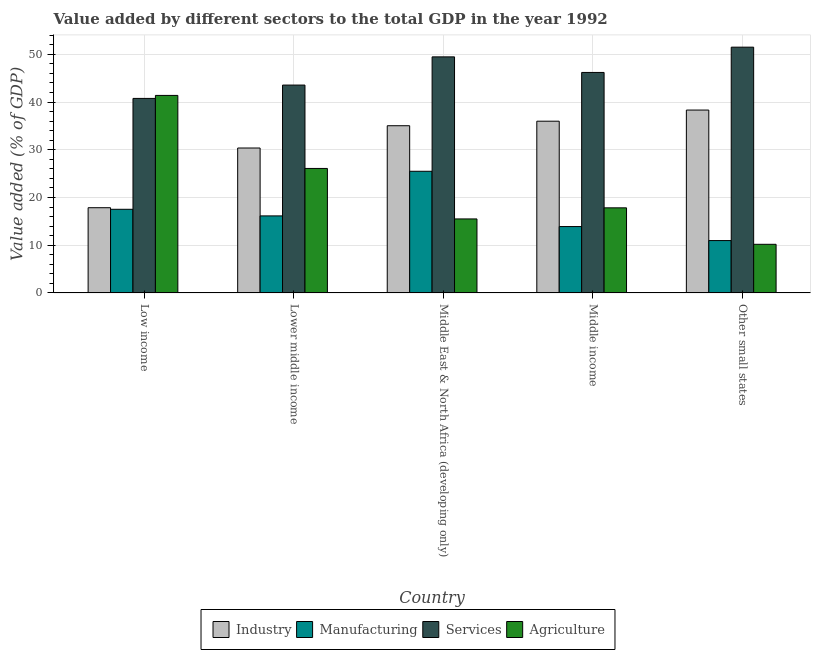How many different coloured bars are there?
Keep it short and to the point. 4. How many groups of bars are there?
Give a very brief answer. 5. How many bars are there on the 3rd tick from the left?
Provide a succinct answer. 4. What is the value added by services sector in Other small states?
Your answer should be compact. 51.49. Across all countries, what is the maximum value added by agricultural sector?
Provide a succinct answer. 41.39. Across all countries, what is the minimum value added by manufacturing sector?
Your answer should be very brief. 10.97. In which country was the value added by industrial sector maximum?
Ensure brevity in your answer.  Other small states. In which country was the value added by industrial sector minimum?
Make the answer very short. Low income. What is the total value added by manufacturing sector in the graph?
Provide a short and direct response. 84.04. What is the difference between the value added by agricultural sector in Low income and that in Middle income?
Ensure brevity in your answer.  23.56. What is the difference between the value added by agricultural sector in Low income and the value added by services sector in Middle income?
Make the answer very short. -4.81. What is the average value added by industrial sector per country?
Provide a short and direct response. 31.51. What is the difference between the value added by industrial sector and value added by services sector in Middle income?
Your answer should be compact. -10.21. In how many countries, is the value added by industrial sector greater than 34 %?
Make the answer very short. 3. What is the ratio of the value added by industrial sector in Lower middle income to that in Middle East & North Africa (developing only)?
Provide a succinct answer. 0.87. Is the value added by manufacturing sector in Low income less than that in Other small states?
Make the answer very short. No. Is the difference between the value added by services sector in Low income and Other small states greater than the difference between the value added by agricultural sector in Low income and Other small states?
Offer a very short reply. No. What is the difference between the highest and the second highest value added by agricultural sector?
Provide a succinct answer. 15.3. What is the difference between the highest and the lowest value added by services sector?
Ensure brevity in your answer.  10.74. In how many countries, is the value added by industrial sector greater than the average value added by industrial sector taken over all countries?
Offer a terse response. 3. Is the sum of the value added by agricultural sector in Low income and Middle East & North Africa (developing only) greater than the maximum value added by manufacturing sector across all countries?
Ensure brevity in your answer.  Yes. Is it the case that in every country, the sum of the value added by services sector and value added by manufacturing sector is greater than the sum of value added by agricultural sector and value added by industrial sector?
Your answer should be very brief. Yes. What does the 3rd bar from the left in Other small states represents?
Provide a short and direct response. Services. What does the 4th bar from the right in Middle East & North Africa (developing only) represents?
Your answer should be very brief. Industry. Is it the case that in every country, the sum of the value added by industrial sector and value added by manufacturing sector is greater than the value added by services sector?
Your answer should be compact. No. How many bars are there?
Your response must be concise. 20. Are all the bars in the graph horizontal?
Give a very brief answer. No. Does the graph contain any zero values?
Make the answer very short. No. Where does the legend appear in the graph?
Keep it short and to the point. Bottom center. How are the legend labels stacked?
Provide a succinct answer. Horizontal. What is the title of the graph?
Provide a short and direct response. Value added by different sectors to the total GDP in the year 1992. What is the label or title of the Y-axis?
Provide a short and direct response. Value added (% of GDP). What is the Value added (% of GDP) in Industry in Low income?
Keep it short and to the point. 17.86. What is the Value added (% of GDP) of Manufacturing in Low income?
Provide a succinct answer. 17.53. What is the Value added (% of GDP) of Services in Low income?
Your answer should be very brief. 40.76. What is the Value added (% of GDP) in Agriculture in Low income?
Your answer should be very brief. 41.39. What is the Value added (% of GDP) of Industry in Lower middle income?
Provide a short and direct response. 30.37. What is the Value added (% of GDP) in Manufacturing in Lower middle income?
Keep it short and to the point. 16.14. What is the Value added (% of GDP) of Services in Lower middle income?
Ensure brevity in your answer.  43.55. What is the Value added (% of GDP) in Agriculture in Lower middle income?
Keep it short and to the point. 26.08. What is the Value added (% of GDP) in Industry in Middle East & North Africa (developing only)?
Your answer should be compact. 35.03. What is the Value added (% of GDP) in Manufacturing in Middle East & North Africa (developing only)?
Offer a very short reply. 25.49. What is the Value added (% of GDP) in Services in Middle East & North Africa (developing only)?
Provide a short and direct response. 49.46. What is the Value added (% of GDP) in Agriculture in Middle East & North Africa (developing only)?
Give a very brief answer. 15.5. What is the Value added (% of GDP) of Industry in Middle income?
Offer a very short reply. 35.98. What is the Value added (% of GDP) in Manufacturing in Middle income?
Your response must be concise. 13.91. What is the Value added (% of GDP) of Services in Middle income?
Your answer should be very brief. 46.2. What is the Value added (% of GDP) of Agriculture in Middle income?
Offer a very short reply. 17.83. What is the Value added (% of GDP) in Industry in Other small states?
Provide a short and direct response. 38.32. What is the Value added (% of GDP) of Manufacturing in Other small states?
Your answer should be compact. 10.97. What is the Value added (% of GDP) of Services in Other small states?
Your response must be concise. 51.49. What is the Value added (% of GDP) in Agriculture in Other small states?
Ensure brevity in your answer.  10.19. Across all countries, what is the maximum Value added (% of GDP) of Industry?
Provide a short and direct response. 38.32. Across all countries, what is the maximum Value added (% of GDP) in Manufacturing?
Offer a terse response. 25.49. Across all countries, what is the maximum Value added (% of GDP) in Services?
Offer a very short reply. 51.49. Across all countries, what is the maximum Value added (% of GDP) in Agriculture?
Your response must be concise. 41.39. Across all countries, what is the minimum Value added (% of GDP) in Industry?
Provide a succinct answer. 17.86. Across all countries, what is the minimum Value added (% of GDP) of Manufacturing?
Your answer should be compact. 10.97. Across all countries, what is the minimum Value added (% of GDP) in Services?
Make the answer very short. 40.76. Across all countries, what is the minimum Value added (% of GDP) of Agriculture?
Your answer should be compact. 10.19. What is the total Value added (% of GDP) of Industry in the graph?
Provide a succinct answer. 157.56. What is the total Value added (% of GDP) of Manufacturing in the graph?
Offer a very short reply. 84.04. What is the total Value added (% of GDP) of Services in the graph?
Make the answer very short. 231.46. What is the total Value added (% of GDP) in Agriculture in the graph?
Offer a terse response. 110.99. What is the difference between the Value added (% of GDP) of Industry in Low income and that in Lower middle income?
Provide a short and direct response. -12.51. What is the difference between the Value added (% of GDP) of Manufacturing in Low income and that in Lower middle income?
Offer a terse response. 1.38. What is the difference between the Value added (% of GDP) of Services in Low income and that in Lower middle income?
Keep it short and to the point. -2.79. What is the difference between the Value added (% of GDP) in Agriculture in Low income and that in Lower middle income?
Offer a very short reply. 15.3. What is the difference between the Value added (% of GDP) of Industry in Low income and that in Middle East & North Africa (developing only)?
Keep it short and to the point. -17.18. What is the difference between the Value added (% of GDP) in Manufacturing in Low income and that in Middle East & North Africa (developing only)?
Keep it short and to the point. -7.97. What is the difference between the Value added (% of GDP) in Services in Low income and that in Middle East & North Africa (developing only)?
Your response must be concise. -8.7. What is the difference between the Value added (% of GDP) of Agriculture in Low income and that in Middle East & North Africa (developing only)?
Give a very brief answer. 25.88. What is the difference between the Value added (% of GDP) in Industry in Low income and that in Middle income?
Offer a very short reply. -18.13. What is the difference between the Value added (% of GDP) of Manufacturing in Low income and that in Middle income?
Offer a terse response. 3.62. What is the difference between the Value added (% of GDP) of Services in Low income and that in Middle income?
Give a very brief answer. -5.44. What is the difference between the Value added (% of GDP) of Agriculture in Low income and that in Middle income?
Your response must be concise. 23.56. What is the difference between the Value added (% of GDP) in Industry in Low income and that in Other small states?
Offer a terse response. -20.46. What is the difference between the Value added (% of GDP) of Manufacturing in Low income and that in Other small states?
Your response must be concise. 6.55. What is the difference between the Value added (% of GDP) in Services in Low income and that in Other small states?
Make the answer very short. -10.74. What is the difference between the Value added (% of GDP) in Agriculture in Low income and that in Other small states?
Provide a short and direct response. 31.2. What is the difference between the Value added (% of GDP) in Industry in Lower middle income and that in Middle East & North Africa (developing only)?
Offer a terse response. -4.67. What is the difference between the Value added (% of GDP) in Manufacturing in Lower middle income and that in Middle East & North Africa (developing only)?
Your response must be concise. -9.35. What is the difference between the Value added (% of GDP) of Services in Lower middle income and that in Middle East & North Africa (developing only)?
Give a very brief answer. -5.91. What is the difference between the Value added (% of GDP) in Agriculture in Lower middle income and that in Middle East & North Africa (developing only)?
Provide a succinct answer. 10.58. What is the difference between the Value added (% of GDP) in Industry in Lower middle income and that in Middle income?
Ensure brevity in your answer.  -5.62. What is the difference between the Value added (% of GDP) in Manufacturing in Lower middle income and that in Middle income?
Your answer should be very brief. 2.23. What is the difference between the Value added (% of GDP) in Services in Lower middle income and that in Middle income?
Keep it short and to the point. -2.65. What is the difference between the Value added (% of GDP) of Agriculture in Lower middle income and that in Middle income?
Keep it short and to the point. 8.25. What is the difference between the Value added (% of GDP) in Industry in Lower middle income and that in Other small states?
Your answer should be compact. -7.95. What is the difference between the Value added (% of GDP) in Manufacturing in Lower middle income and that in Other small states?
Your answer should be compact. 5.17. What is the difference between the Value added (% of GDP) in Services in Lower middle income and that in Other small states?
Keep it short and to the point. -7.94. What is the difference between the Value added (% of GDP) of Agriculture in Lower middle income and that in Other small states?
Provide a succinct answer. 15.89. What is the difference between the Value added (% of GDP) of Industry in Middle East & North Africa (developing only) and that in Middle income?
Offer a very short reply. -0.95. What is the difference between the Value added (% of GDP) in Manufacturing in Middle East & North Africa (developing only) and that in Middle income?
Keep it short and to the point. 11.58. What is the difference between the Value added (% of GDP) of Services in Middle East & North Africa (developing only) and that in Middle income?
Provide a short and direct response. 3.26. What is the difference between the Value added (% of GDP) of Agriculture in Middle East & North Africa (developing only) and that in Middle income?
Offer a terse response. -2.33. What is the difference between the Value added (% of GDP) of Industry in Middle East & North Africa (developing only) and that in Other small states?
Your response must be concise. -3.28. What is the difference between the Value added (% of GDP) of Manufacturing in Middle East & North Africa (developing only) and that in Other small states?
Your response must be concise. 14.52. What is the difference between the Value added (% of GDP) in Services in Middle East & North Africa (developing only) and that in Other small states?
Provide a succinct answer. -2.03. What is the difference between the Value added (% of GDP) of Agriculture in Middle East & North Africa (developing only) and that in Other small states?
Make the answer very short. 5.32. What is the difference between the Value added (% of GDP) in Industry in Middle income and that in Other small states?
Offer a terse response. -2.33. What is the difference between the Value added (% of GDP) in Manufacturing in Middle income and that in Other small states?
Make the answer very short. 2.93. What is the difference between the Value added (% of GDP) in Services in Middle income and that in Other small states?
Keep it short and to the point. -5.3. What is the difference between the Value added (% of GDP) of Agriculture in Middle income and that in Other small states?
Keep it short and to the point. 7.64. What is the difference between the Value added (% of GDP) of Industry in Low income and the Value added (% of GDP) of Manufacturing in Lower middle income?
Make the answer very short. 1.72. What is the difference between the Value added (% of GDP) of Industry in Low income and the Value added (% of GDP) of Services in Lower middle income?
Provide a succinct answer. -25.69. What is the difference between the Value added (% of GDP) in Industry in Low income and the Value added (% of GDP) in Agriculture in Lower middle income?
Keep it short and to the point. -8.22. What is the difference between the Value added (% of GDP) of Manufacturing in Low income and the Value added (% of GDP) of Services in Lower middle income?
Make the answer very short. -26.02. What is the difference between the Value added (% of GDP) in Manufacturing in Low income and the Value added (% of GDP) in Agriculture in Lower middle income?
Provide a succinct answer. -8.56. What is the difference between the Value added (% of GDP) in Services in Low income and the Value added (% of GDP) in Agriculture in Lower middle income?
Your answer should be very brief. 14.67. What is the difference between the Value added (% of GDP) in Industry in Low income and the Value added (% of GDP) in Manufacturing in Middle East & North Africa (developing only)?
Offer a terse response. -7.63. What is the difference between the Value added (% of GDP) of Industry in Low income and the Value added (% of GDP) of Services in Middle East & North Africa (developing only)?
Offer a very short reply. -31.6. What is the difference between the Value added (% of GDP) of Industry in Low income and the Value added (% of GDP) of Agriculture in Middle East & North Africa (developing only)?
Make the answer very short. 2.35. What is the difference between the Value added (% of GDP) of Manufacturing in Low income and the Value added (% of GDP) of Services in Middle East & North Africa (developing only)?
Make the answer very short. -31.94. What is the difference between the Value added (% of GDP) in Manufacturing in Low income and the Value added (% of GDP) in Agriculture in Middle East & North Africa (developing only)?
Make the answer very short. 2.02. What is the difference between the Value added (% of GDP) in Services in Low income and the Value added (% of GDP) in Agriculture in Middle East & North Africa (developing only)?
Provide a short and direct response. 25.25. What is the difference between the Value added (% of GDP) in Industry in Low income and the Value added (% of GDP) in Manufacturing in Middle income?
Your response must be concise. 3.95. What is the difference between the Value added (% of GDP) of Industry in Low income and the Value added (% of GDP) of Services in Middle income?
Offer a very short reply. -28.34. What is the difference between the Value added (% of GDP) in Industry in Low income and the Value added (% of GDP) in Agriculture in Middle income?
Your response must be concise. 0.03. What is the difference between the Value added (% of GDP) in Manufacturing in Low income and the Value added (% of GDP) in Services in Middle income?
Give a very brief answer. -28.67. What is the difference between the Value added (% of GDP) in Manufacturing in Low income and the Value added (% of GDP) in Agriculture in Middle income?
Your answer should be very brief. -0.3. What is the difference between the Value added (% of GDP) of Services in Low income and the Value added (% of GDP) of Agriculture in Middle income?
Give a very brief answer. 22.93. What is the difference between the Value added (% of GDP) in Industry in Low income and the Value added (% of GDP) in Manufacturing in Other small states?
Ensure brevity in your answer.  6.88. What is the difference between the Value added (% of GDP) in Industry in Low income and the Value added (% of GDP) in Services in Other small states?
Make the answer very short. -33.64. What is the difference between the Value added (% of GDP) of Industry in Low income and the Value added (% of GDP) of Agriculture in Other small states?
Ensure brevity in your answer.  7.67. What is the difference between the Value added (% of GDP) of Manufacturing in Low income and the Value added (% of GDP) of Services in Other small states?
Your answer should be very brief. -33.97. What is the difference between the Value added (% of GDP) in Manufacturing in Low income and the Value added (% of GDP) in Agriculture in Other small states?
Your response must be concise. 7.34. What is the difference between the Value added (% of GDP) of Services in Low income and the Value added (% of GDP) of Agriculture in Other small states?
Make the answer very short. 30.57. What is the difference between the Value added (% of GDP) in Industry in Lower middle income and the Value added (% of GDP) in Manufacturing in Middle East & North Africa (developing only)?
Your answer should be very brief. 4.87. What is the difference between the Value added (% of GDP) of Industry in Lower middle income and the Value added (% of GDP) of Services in Middle East & North Africa (developing only)?
Make the answer very short. -19.09. What is the difference between the Value added (% of GDP) of Industry in Lower middle income and the Value added (% of GDP) of Agriculture in Middle East & North Africa (developing only)?
Your response must be concise. 14.86. What is the difference between the Value added (% of GDP) of Manufacturing in Lower middle income and the Value added (% of GDP) of Services in Middle East & North Africa (developing only)?
Provide a short and direct response. -33.32. What is the difference between the Value added (% of GDP) in Manufacturing in Lower middle income and the Value added (% of GDP) in Agriculture in Middle East & North Africa (developing only)?
Your answer should be compact. 0.64. What is the difference between the Value added (% of GDP) of Services in Lower middle income and the Value added (% of GDP) of Agriculture in Middle East & North Africa (developing only)?
Provide a short and direct response. 28.05. What is the difference between the Value added (% of GDP) of Industry in Lower middle income and the Value added (% of GDP) of Manufacturing in Middle income?
Make the answer very short. 16.46. What is the difference between the Value added (% of GDP) in Industry in Lower middle income and the Value added (% of GDP) in Services in Middle income?
Provide a succinct answer. -15.83. What is the difference between the Value added (% of GDP) in Industry in Lower middle income and the Value added (% of GDP) in Agriculture in Middle income?
Give a very brief answer. 12.54. What is the difference between the Value added (% of GDP) in Manufacturing in Lower middle income and the Value added (% of GDP) in Services in Middle income?
Your answer should be very brief. -30.05. What is the difference between the Value added (% of GDP) of Manufacturing in Lower middle income and the Value added (% of GDP) of Agriculture in Middle income?
Offer a terse response. -1.69. What is the difference between the Value added (% of GDP) in Services in Lower middle income and the Value added (% of GDP) in Agriculture in Middle income?
Provide a succinct answer. 25.72. What is the difference between the Value added (% of GDP) in Industry in Lower middle income and the Value added (% of GDP) in Manufacturing in Other small states?
Offer a very short reply. 19.39. What is the difference between the Value added (% of GDP) of Industry in Lower middle income and the Value added (% of GDP) of Services in Other small states?
Make the answer very short. -21.13. What is the difference between the Value added (% of GDP) in Industry in Lower middle income and the Value added (% of GDP) in Agriculture in Other small states?
Your answer should be very brief. 20.18. What is the difference between the Value added (% of GDP) of Manufacturing in Lower middle income and the Value added (% of GDP) of Services in Other small states?
Keep it short and to the point. -35.35. What is the difference between the Value added (% of GDP) of Manufacturing in Lower middle income and the Value added (% of GDP) of Agriculture in Other small states?
Offer a very short reply. 5.95. What is the difference between the Value added (% of GDP) in Services in Lower middle income and the Value added (% of GDP) in Agriculture in Other small states?
Offer a terse response. 33.36. What is the difference between the Value added (% of GDP) in Industry in Middle East & North Africa (developing only) and the Value added (% of GDP) in Manufacturing in Middle income?
Give a very brief answer. 21.13. What is the difference between the Value added (% of GDP) in Industry in Middle East & North Africa (developing only) and the Value added (% of GDP) in Services in Middle income?
Your answer should be compact. -11.16. What is the difference between the Value added (% of GDP) of Industry in Middle East & North Africa (developing only) and the Value added (% of GDP) of Agriculture in Middle income?
Provide a short and direct response. 17.2. What is the difference between the Value added (% of GDP) of Manufacturing in Middle East & North Africa (developing only) and the Value added (% of GDP) of Services in Middle income?
Ensure brevity in your answer.  -20.7. What is the difference between the Value added (% of GDP) in Manufacturing in Middle East & North Africa (developing only) and the Value added (% of GDP) in Agriculture in Middle income?
Make the answer very short. 7.66. What is the difference between the Value added (% of GDP) in Services in Middle East & North Africa (developing only) and the Value added (% of GDP) in Agriculture in Middle income?
Your answer should be very brief. 31.63. What is the difference between the Value added (% of GDP) in Industry in Middle East & North Africa (developing only) and the Value added (% of GDP) in Manufacturing in Other small states?
Offer a terse response. 24.06. What is the difference between the Value added (% of GDP) of Industry in Middle East & North Africa (developing only) and the Value added (% of GDP) of Services in Other small states?
Your answer should be compact. -16.46. What is the difference between the Value added (% of GDP) in Industry in Middle East & North Africa (developing only) and the Value added (% of GDP) in Agriculture in Other small states?
Give a very brief answer. 24.85. What is the difference between the Value added (% of GDP) of Manufacturing in Middle East & North Africa (developing only) and the Value added (% of GDP) of Services in Other small states?
Your answer should be compact. -26. What is the difference between the Value added (% of GDP) of Manufacturing in Middle East & North Africa (developing only) and the Value added (% of GDP) of Agriculture in Other small states?
Keep it short and to the point. 15.3. What is the difference between the Value added (% of GDP) in Services in Middle East & North Africa (developing only) and the Value added (% of GDP) in Agriculture in Other small states?
Offer a very short reply. 39.27. What is the difference between the Value added (% of GDP) of Industry in Middle income and the Value added (% of GDP) of Manufacturing in Other small states?
Make the answer very short. 25.01. What is the difference between the Value added (% of GDP) in Industry in Middle income and the Value added (% of GDP) in Services in Other small states?
Offer a very short reply. -15.51. What is the difference between the Value added (% of GDP) of Industry in Middle income and the Value added (% of GDP) of Agriculture in Other small states?
Ensure brevity in your answer.  25.79. What is the difference between the Value added (% of GDP) of Manufacturing in Middle income and the Value added (% of GDP) of Services in Other small states?
Offer a terse response. -37.59. What is the difference between the Value added (% of GDP) of Manufacturing in Middle income and the Value added (% of GDP) of Agriculture in Other small states?
Make the answer very short. 3.72. What is the difference between the Value added (% of GDP) in Services in Middle income and the Value added (% of GDP) in Agriculture in Other small states?
Provide a succinct answer. 36.01. What is the average Value added (% of GDP) in Industry per country?
Your response must be concise. 31.51. What is the average Value added (% of GDP) in Manufacturing per country?
Your answer should be very brief. 16.81. What is the average Value added (% of GDP) in Services per country?
Your answer should be compact. 46.29. What is the average Value added (% of GDP) of Agriculture per country?
Your answer should be compact. 22.2. What is the difference between the Value added (% of GDP) of Industry and Value added (% of GDP) of Manufacturing in Low income?
Your response must be concise. 0.33. What is the difference between the Value added (% of GDP) in Industry and Value added (% of GDP) in Services in Low income?
Your answer should be compact. -22.9. What is the difference between the Value added (% of GDP) of Industry and Value added (% of GDP) of Agriculture in Low income?
Give a very brief answer. -23.53. What is the difference between the Value added (% of GDP) of Manufacturing and Value added (% of GDP) of Services in Low income?
Your answer should be very brief. -23.23. What is the difference between the Value added (% of GDP) of Manufacturing and Value added (% of GDP) of Agriculture in Low income?
Provide a succinct answer. -23.86. What is the difference between the Value added (% of GDP) in Services and Value added (% of GDP) in Agriculture in Low income?
Make the answer very short. -0.63. What is the difference between the Value added (% of GDP) in Industry and Value added (% of GDP) in Manufacturing in Lower middle income?
Provide a short and direct response. 14.22. What is the difference between the Value added (% of GDP) in Industry and Value added (% of GDP) in Services in Lower middle income?
Your answer should be compact. -13.18. What is the difference between the Value added (% of GDP) of Industry and Value added (% of GDP) of Agriculture in Lower middle income?
Offer a very short reply. 4.28. What is the difference between the Value added (% of GDP) in Manufacturing and Value added (% of GDP) in Services in Lower middle income?
Offer a very short reply. -27.41. What is the difference between the Value added (% of GDP) of Manufacturing and Value added (% of GDP) of Agriculture in Lower middle income?
Offer a very short reply. -9.94. What is the difference between the Value added (% of GDP) in Services and Value added (% of GDP) in Agriculture in Lower middle income?
Your answer should be very brief. 17.47. What is the difference between the Value added (% of GDP) in Industry and Value added (% of GDP) in Manufacturing in Middle East & North Africa (developing only)?
Offer a very short reply. 9.54. What is the difference between the Value added (% of GDP) of Industry and Value added (% of GDP) of Services in Middle East & North Africa (developing only)?
Give a very brief answer. -14.43. What is the difference between the Value added (% of GDP) of Industry and Value added (% of GDP) of Agriculture in Middle East & North Africa (developing only)?
Keep it short and to the point. 19.53. What is the difference between the Value added (% of GDP) of Manufacturing and Value added (% of GDP) of Services in Middle East & North Africa (developing only)?
Provide a short and direct response. -23.97. What is the difference between the Value added (% of GDP) in Manufacturing and Value added (% of GDP) in Agriculture in Middle East & North Africa (developing only)?
Provide a short and direct response. 9.99. What is the difference between the Value added (% of GDP) of Services and Value added (% of GDP) of Agriculture in Middle East & North Africa (developing only)?
Provide a succinct answer. 33.96. What is the difference between the Value added (% of GDP) of Industry and Value added (% of GDP) of Manufacturing in Middle income?
Keep it short and to the point. 22.07. What is the difference between the Value added (% of GDP) in Industry and Value added (% of GDP) in Services in Middle income?
Your answer should be compact. -10.21. What is the difference between the Value added (% of GDP) of Industry and Value added (% of GDP) of Agriculture in Middle income?
Your response must be concise. 18.15. What is the difference between the Value added (% of GDP) of Manufacturing and Value added (% of GDP) of Services in Middle income?
Keep it short and to the point. -32.29. What is the difference between the Value added (% of GDP) of Manufacturing and Value added (% of GDP) of Agriculture in Middle income?
Give a very brief answer. -3.92. What is the difference between the Value added (% of GDP) of Services and Value added (% of GDP) of Agriculture in Middle income?
Your answer should be very brief. 28.37. What is the difference between the Value added (% of GDP) of Industry and Value added (% of GDP) of Manufacturing in Other small states?
Give a very brief answer. 27.34. What is the difference between the Value added (% of GDP) of Industry and Value added (% of GDP) of Services in Other small states?
Give a very brief answer. -13.18. What is the difference between the Value added (% of GDP) in Industry and Value added (% of GDP) in Agriculture in Other small states?
Your response must be concise. 28.13. What is the difference between the Value added (% of GDP) in Manufacturing and Value added (% of GDP) in Services in Other small states?
Your answer should be very brief. -40.52. What is the difference between the Value added (% of GDP) in Manufacturing and Value added (% of GDP) in Agriculture in Other small states?
Provide a succinct answer. 0.78. What is the difference between the Value added (% of GDP) of Services and Value added (% of GDP) of Agriculture in Other small states?
Make the answer very short. 41.31. What is the ratio of the Value added (% of GDP) of Industry in Low income to that in Lower middle income?
Your answer should be compact. 0.59. What is the ratio of the Value added (% of GDP) in Manufacturing in Low income to that in Lower middle income?
Ensure brevity in your answer.  1.09. What is the ratio of the Value added (% of GDP) in Services in Low income to that in Lower middle income?
Provide a short and direct response. 0.94. What is the ratio of the Value added (% of GDP) of Agriculture in Low income to that in Lower middle income?
Provide a short and direct response. 1.59. What is the ratio of the Value added (% of GDP) of Industry in Low income to that in Middle East & North Africa (developing only)?
Your answer should be very brief. 0.51. What is the ratio of the Value added (% of GDP) of Manufacturing in Low income to that in Middle East & North Africa (developing only)?
Your response must be concise. 0.69. What is the ratio of the Value added (% of GDP) of Services in Low income to that in Middle East & North Africa (developing only)?
Provide a succinct answer. 0.82. What is the ratio of the Value added (% of GDP) in Agriculture in Low income to that in Middle East & North Africa (developing only)?
Provide a succinct answer. 2.67. What is the ratio of the Value added (% of GDP) of Industry in Low income to that in Middle income?
Offer a terse response. 0.5. What is the ratio of the Value added (% of GDP) of Manufacturing in Low income to that in Middle income?
Provide a succinct answer. 1.26. What is the ratio of the Value added (% of GDP) in Services in Low income to that in Middle income?
Keep it short and to the point. 0.88. What is the ratio of the Value added (% of GDP) in Agriculture in Low income to that in Middle income?
Offer a very short reply. 2.32. What is the ratio of the Value added (% of GDP) in Industry in Low income to that in Other small states?
Your answer should be very brief. 0.47. What is the ratio of the Value added (% of GDP) of Manufacturing in Low income to that in Other small states?
Ensure brevity in your answer.  1.6. What is the ratio of the Value added (% of GDP) of Services in Low income to that in Other small states?
Keep it short and to the point. 0.79. What is the ratio of the Value added (% of GDP) of Agriculture in Low income to that in Other small states?
Keep it short and to the point. 4.06. What is the ratio of the Value added (% of GDP) of Industry in Lower middle income to that in Middle East & North Africa (developing only)?
Offer a terse response. 0.87. What is the ratio of the Value added (% of GDP) of Manufacturing in Lower middle income to that in Middle East & North Africa (developing only)?
Your answer should be compact. 0.63. What is the ratio of the Value added (% of GDP) of Services in Lower middle income to that in Middle East & North Africa (developing only)?
Your answer should be compact. 0.88. What is the ratio of the Value added (% of GDP) in Agriculture in Lower middle income to that in Middle East & North Africa (developing only)?
Make the answer very short. 1.68. What is the ratio of the Value added (% of GDP) in Industry in Lower middle income to that in Middle income?
Make the answer very short. 0.84. What is the ratio of the Value added (% of GDP) in Manufacturing in Lower middle income to that in Middle income?
Keep it short and to the point. 1.16. What is the ratio of the Value added (% of GDP) of Services in Lower middle income to that in Middle income?
Your answer should be compact. 0.94. What is the ratio of the Value added (% of GDP) of Agriculture in Lower middle income to that in Middle income?
Offer a terse response. 1.46. What is the ratio of the Value added (% of GDP) in Industry in Lower middle income to that in Other small states?
Provide a succinct answer. 0.79. What is the ratio of the Value added (% of GDP) of Manufacturing in Lower middle income to that in Other small states?
Give a very brief answer. 1.47. What is the ratio of the Value added (% of GDP) in Services in Lower middle income to that in Other small states?
Offer a terse response. 0.85. What is the ratio of the Value added (% of GDP) in Agriculture in Lower middle income to that in Other small states?
Offer a terse response. 2.56. What is the ratio of the Value added (% of GDP) in Industry in Middle East & North Africa (developing only) to that in Middle income?
Your answer should be very brief. 0.97. What is the ratio of the Value added (% of GDP) in Manufacturing in Middle East & North Africa (developing only) to that in Middle income?
Your answer should be compact. 1.83. What is the ratio of the Value added (% of GDP) in Services in Middle East & North Africa (developing only) to that in Middle income?
Provide a short and direct response. 1.07. What is the ratio of the Value added (% of GDP) in Agriculture in Middle East & North Africa (developing only) to that in Middle income?
Ensure brevity in your answer.  0.87. What is the ratio of the Value added (% of GDP) of Industry in Middle East & North Africa (developing only) to that in Other small states?
Your response must be concise. 0.91. What is the ratio of the Value added (% of GDP) of Manufacturing in Middle East & North Africa (developing only) to that in Other small states?
Offer a terse response. 2.32. What is the ratio of the Value added (% of GDP) of Services in Middle East & North Africa (developing only) to that in Other small states?
Keep it short and to the point. 0.96. What is the ratio of the Value added (% of GDP) in Agriculture in Middle East & North Africa (developing only) to that in Other small states?
Your answer should be very brief. 1.52. What is the ratio of the Value added (% of GDP) of Industry in Middle income to that in Other small states?
Give a very brief answer. 0.94. What is the ratio of the Value added (% of GDP) of Manufacturing in Middle income to that in Other small states?
Your answer should be very brief. 1.27. What is the ratio of the Value added (% of GDP) of Services in Middle income to that in Other small states?
Give a very brief answer. 0.9. What is the ratio of the Value added (% of GDP) of Agriculture in Middle income to that in Other small states?
Make the answer very short. 1.75. What is the difference between the highest and the second highest Value added (% of GDP) of Industry?
Provide a short and direct response. 2.33. What is the difference between the highest and the second highest Value added (% of GDP) of Manufacturing?
Your answer should be compact. 7.97. What is the difference between the highest and the second highest Value added (% of GDP) of Services?
Make the answer very short. 2.03. What is the difference between the highest and the second highest Value added (% of GDP) in Agriculture?
Offer a terse response. 15.3. What is the difference between the highest and the lowest Value added (% of GDP) in Industry?
Give a very brief answer. 20.46. What is the difference between the highest and the lowest Value added (% of GDP) in Manufacturing?
Your answer should be very brief. 14.52. What is the difference between the highest and the lowest Value added (% of GDP) of Services?
Offer a terse response. 10.74. What is the difference between the highest and the lowest Value added (% of GDP) of Agriculture?
Provide a short and direct response. 31.2. 